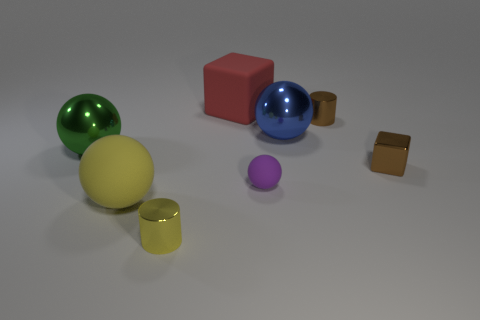Subtract 1 balls. How many balls are left? 3 Add 1 green shiny objects. How many objects exist? 9 Subtract all cylinders. How many objects are left? 6 Add 7 shiny balls. How many shiny balls exist? 9 Subtract 0 purple blocks. How many objects are left? 8 Subtract all big green shiny objects. Subtract all brown cylinders. How many objects are left? 6 Add 6 red rubber cubes. How many red rubber cubes are left? 7 